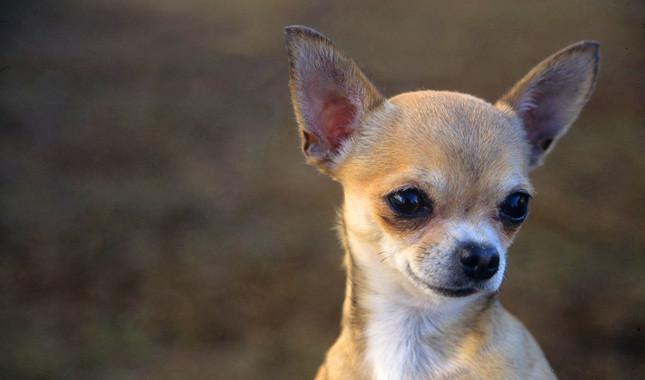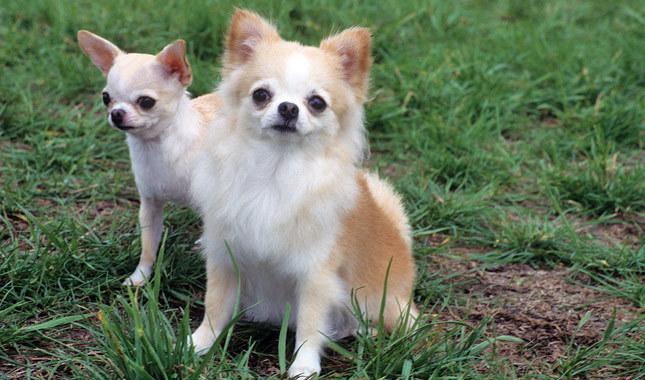The first image is the image on the left, the second image is the image on the right. Considering the images on both sides, is "The dogs in the image on the right are sitting on grass." valid? Answer yes or no. Yes. 